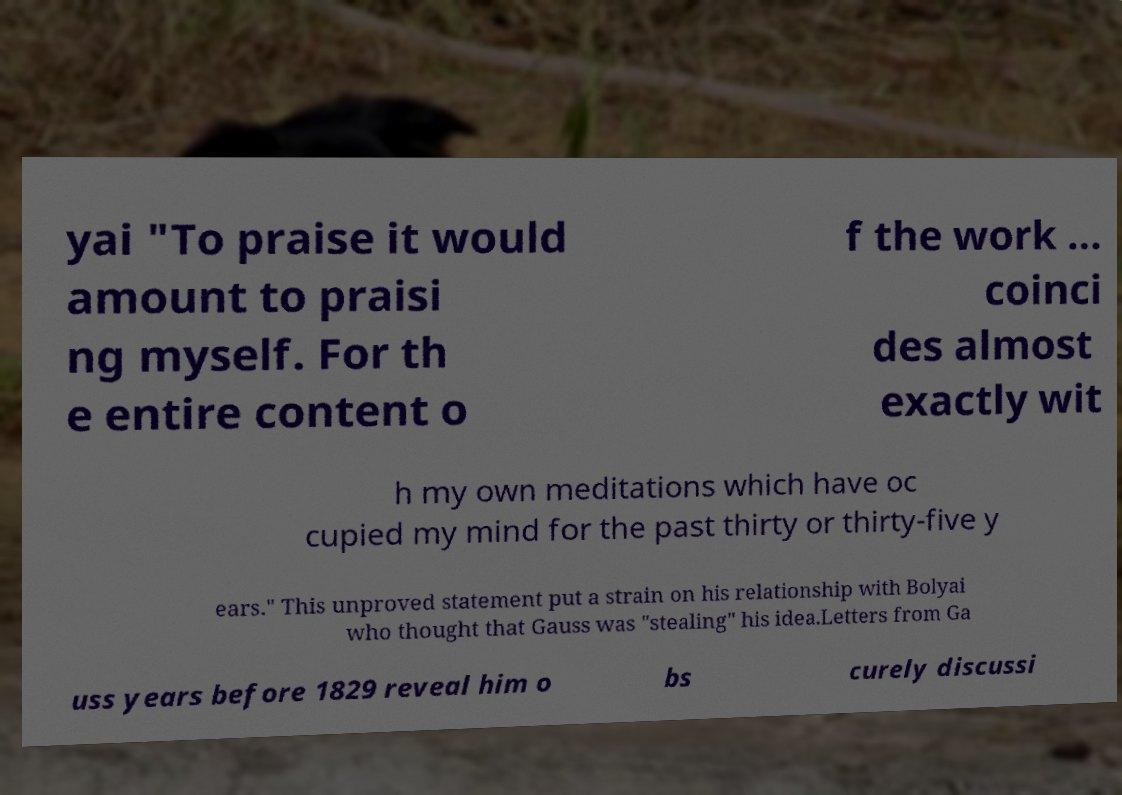What messages or text are displayed in this image? I need them in a readable, typed format. yai "To praise it would amount to praisi ng myself. For th e entire content o f the work ... coinci des almost exactly wit h my own meditations which have oc cupied my mind for the past thirty or thirty-five y ears." This unproved statement put a strain on his relationship with Bolyai who thought that Gauss was "stealing" his idea.Letters from Ga uss years before 1829 reveal him o bs curely discussi 